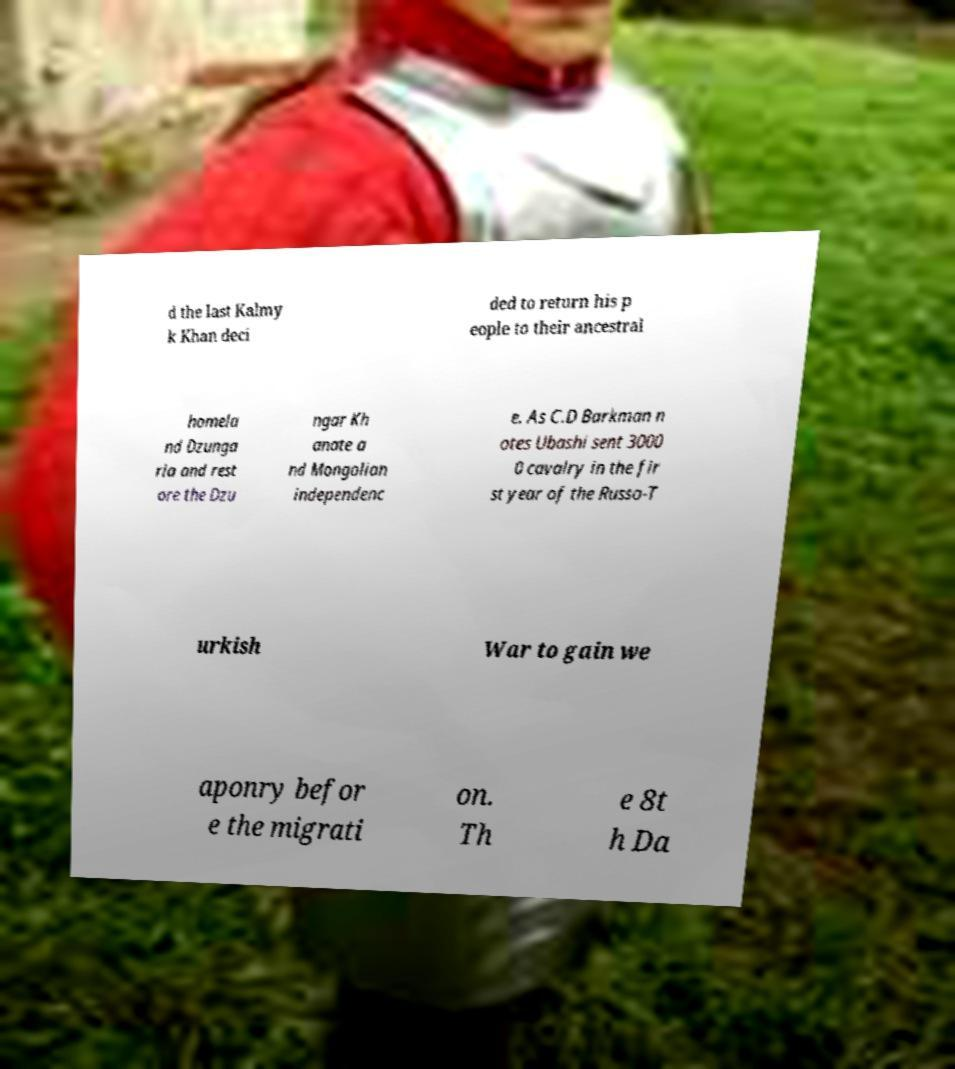Can you accurately transcribe the text from the provided image for me? d the last Kalmy k Khan deci ded to return his p eople to their ancestral homela nd Dzunga ria and rest ore the Dzu ngar Kh anate a nd Mongolian independenc e. As C.D Barkman n otes Ubashi sent 3000 0 cavalry in the fir st year of the Russo-T urkish War to gain we aponry befor e the migrati on. Th e 8t h Da 